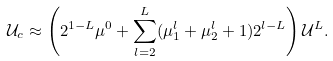<formula> <loc_0><loc_0><loc_500><loc_500>\mathcal { U } _ { c } \approx \left ( 2 ^ { 1 - L } \mu ^ { 0 } + \sum _ { l = 2 } ^ { L } ( \mu _ { 1 } ^ { l } + \mu _ { 2 } ^ { l } + 1 ) 2 ^ { l - L } \right ) \mathcal { U } ^ { L } .</formula> 